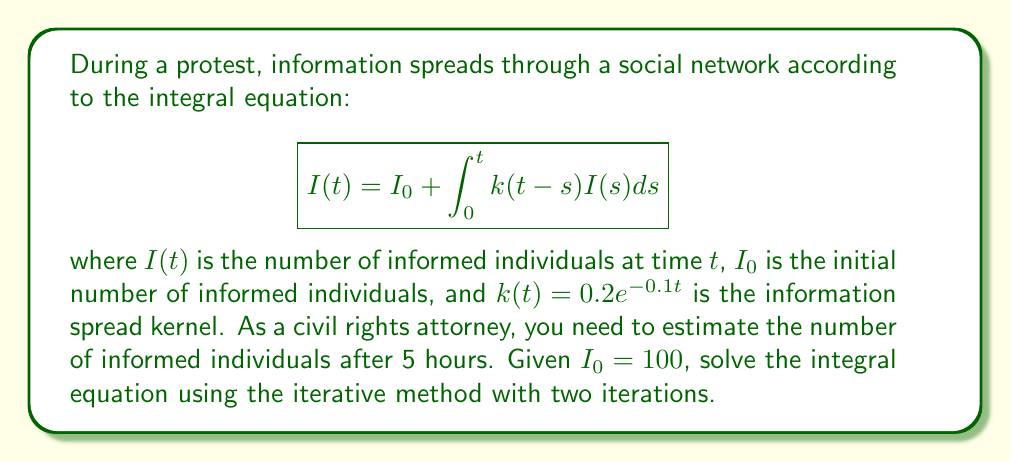Solve this math problem. To solve this integral equation using the iterative method:

1) Start with the initial approximation $I_0(t) = I_0 = 100$

2) For the first iteration:
   $$I_1(t) = 100 + \int_0^t 0.2e^{-0.1(t-s)}100ds$$
   $$= 100 + 20\int_0^t e^{-0.1(t-s)}ds$$
   $$= 100 + 20[-10e^{-0.1(t-s)}]_0^t$$
   $$= 100 + 200(1-e^{-0.1t})$$

3) For the second iteration:
   $$I_2(t) = 100 + \int_0^t 0.2e^{-0.1(t-s)}[100 + 200(1-e^{-0.1s})]ds$$
   $$= 100 + 20\int_0^t e^{-0.1(t-s)}ds + 40\int_0^t e^{-0.1(t-s)}(1-e^{-0.1s})ds$$
   $$= 100 + 200(1-e^{-0.1t}) + 40[10(1-e^{-0.1t}) - (10-10e^{-0.2t})]$$
   $$= 100 + 200(1-e^{-0.1t}) + 400(1-e^{-0.1t}) - 400 + 400e^{-0.2t}$$
   $$= 300 + 600(1-e^{-0.1t}) + 400e^{-0.2t}$$

4) Evaluate $I_2(t)$ at $t=5$:
   $$I_2(5) = 300 + 600(1-e^{-0.5}) + 400e^{-1}$$
   $$\approx 300 + 600(0.3935) + 400(0.3679)$$
   $$\approx 300 + 236.1 + 147.16$$
   $$\approx 683.26$$
Answer: 683 individuals (rounded to nearest whole number) 